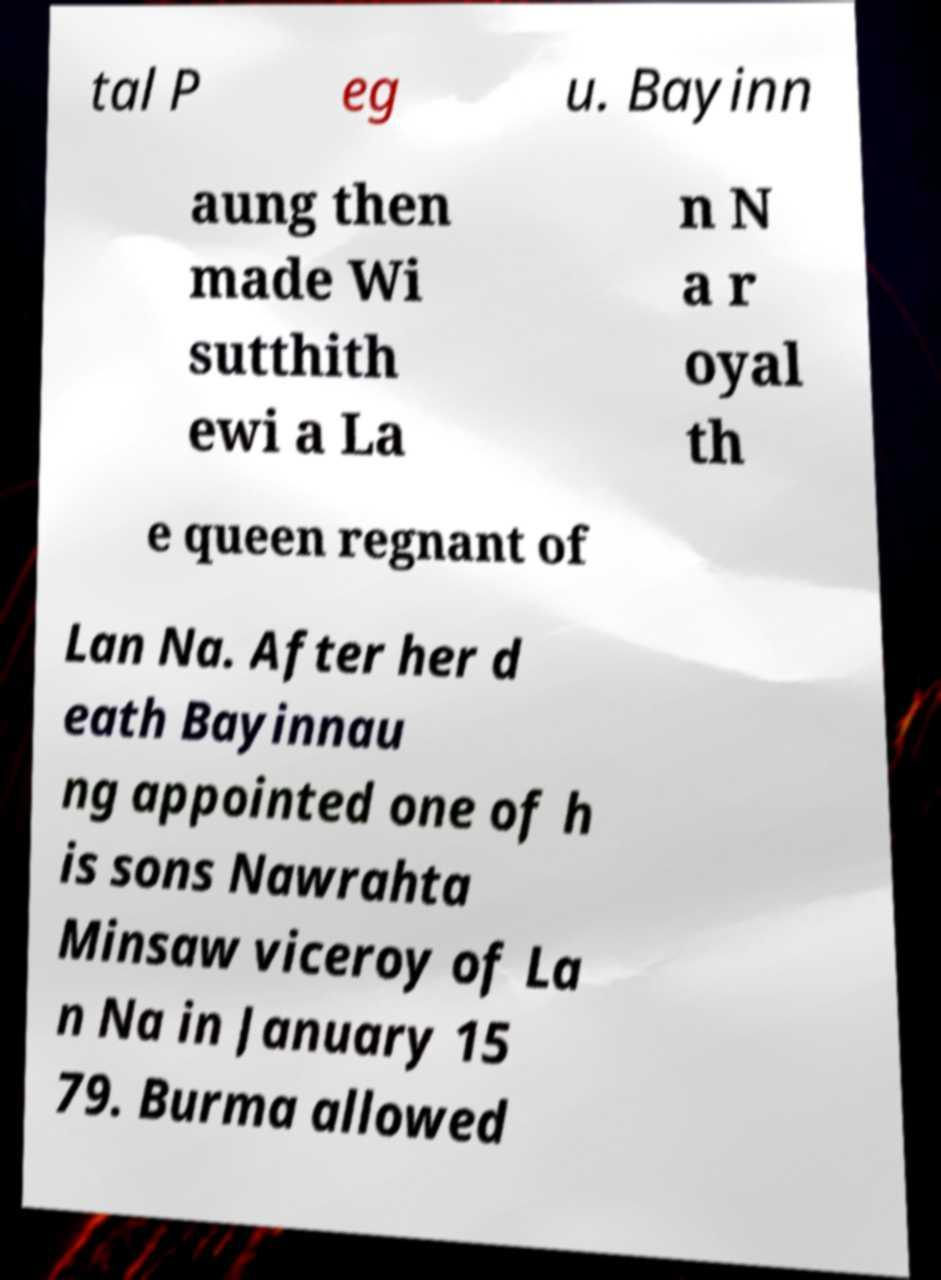Can you accurately transcribe the text from the provided image for me? tal P eg u. Bayinn aung then made Wi sutthith ewi a La n N a r oyal th e queen regnant of Lan Na. After her d eath Bayinnau ng appointed one of h is sons Nawrahta Minsaw viceroy of La n Na in January 15 79. Burma allowed 